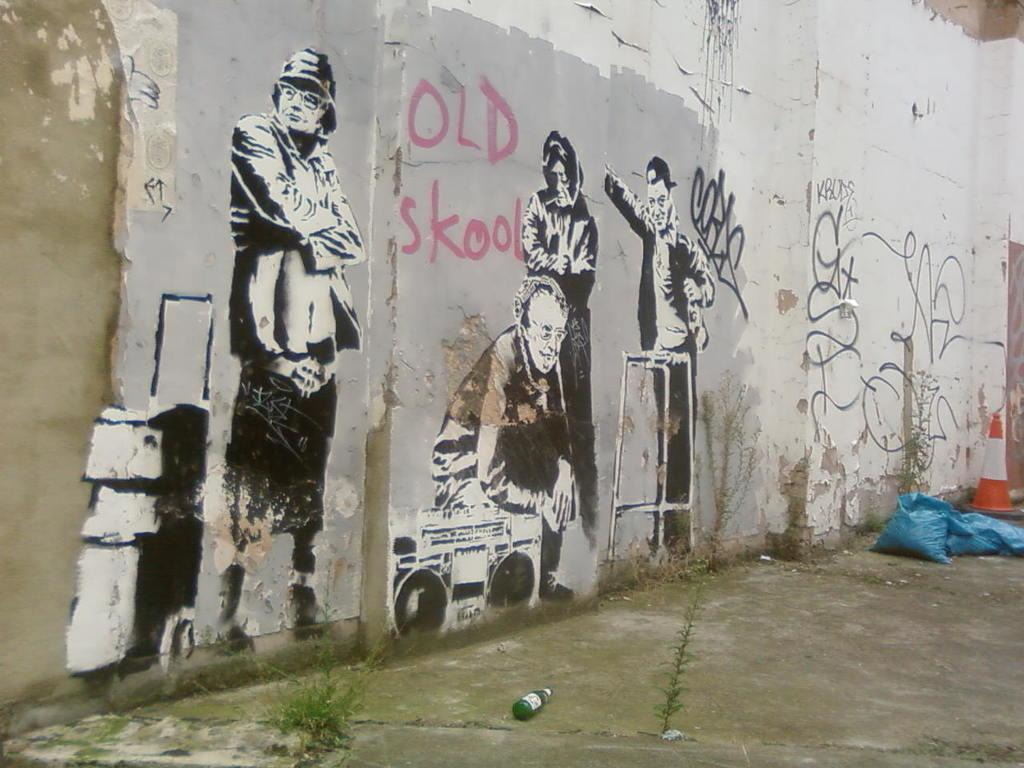What type of surface can be seen in the image? There is ground visible in the image. What object is present in the image that might contain a liquid? There is a bottle in the image. What type of disposable containers are visible in the image? There are plastic bags in the image. What type of structure can be seen in the image that is used for traffic control? There is a traffic pole in the image. What large, man-made structure is present in the image? There is a huge wall in the image. What type of artwork can be seen on the wall? There are paintings of persons on the wall. What type of hat is the person wearing in the image? There are no persons present in the image; only a wall with paintings of persons. How does the loss of the front door affect the image? There is no mention of a front door or any loss in the image; it only features a wall with paintings of persons, a traffic pole, plastic bags, a bottle, and ground. 